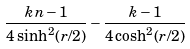Convert formula to latex. <formula><loc_0><loc_0><loc_500><loc_500>\frac { k n - 1 } { 4 \sinh ^ { 2 } ( r / 2 ) } - \frac { k - 1 } { 4 \cosh ^ { 2 } ( r / 2 ) }</formula> 